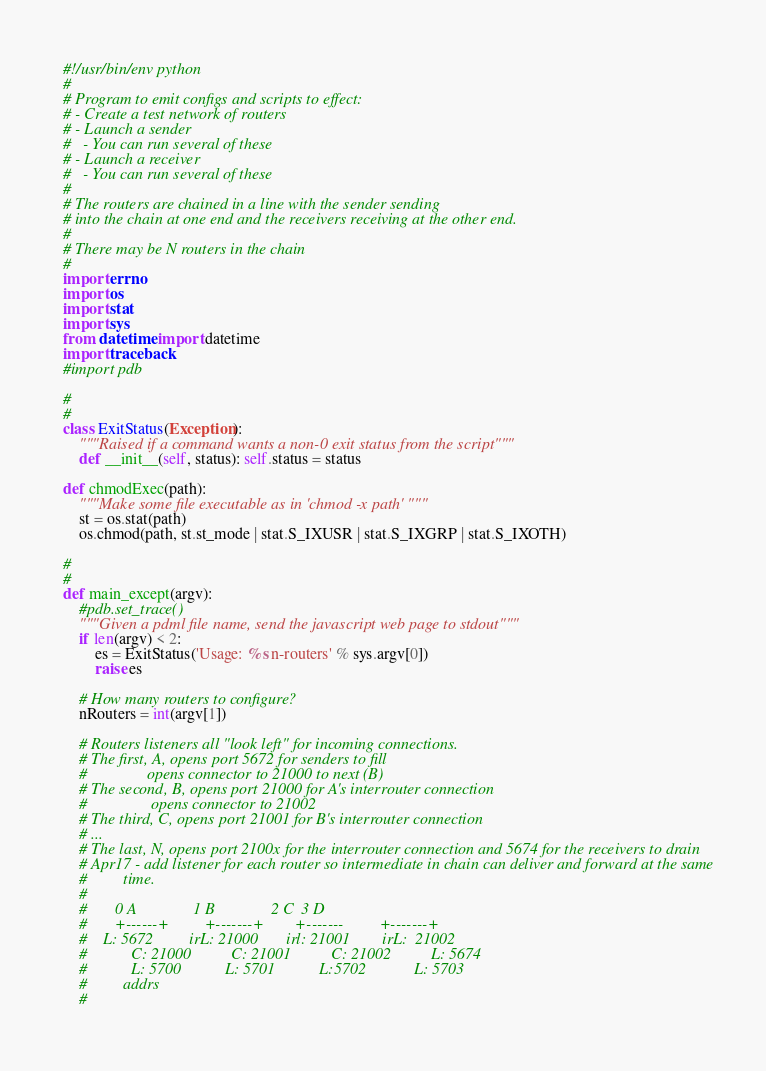Convert code to text. <code><loc_0><loc_0><loc_500><loc_500><_Python_>#!/usr/bin/env python
#
# Program to emit configs and scripts to effect:
# - Create a test network of routers
# - Launch a sender
#   - You can run several of these
# - Launch a receiver
#   - You can run several of these
#
# The routers are chained in a line with the sender sending
# into the chain at one end and the receivers receiving at the other end.
#
# There may be N routers in the chain
#
import errno
import os
import stat
import sys
from datetime import datetime
import traceback
#import pdb

#
#
class ExitStatus(Exception):
    """Raised if a command wants a non-0 exit status from the script"""
    def __init__(self, status): self.status = status

def chmodExec(path):
    """Make some file executable as in 'chmod -x path' """
    st = os.stat(path)
    os.chmod(path, st.st_mode | stat.S_IXUSR | stat.S_IXGRP | stat.S_IXOTH)

#
#
def main_except(argv):
    #pdb.set_trace()
    """Given a pdml file name, send the javascript web page to stdout"""
    if len(argv) < 2:
        es = ExitStatus('Usage: %s n-routers' % sys.argv[0])
        raise es

    # How many routers to configure?
    nRouters = int(argv[1])

    # Routers listeners all "look left" for incoming connections.
    # The first, A, opens port 5672 for senders to fill
    #               opens connector to 21000 to next (B)
    # The second, B, opens port 21000 for A's interrouter connection
    #                opens connector to 21002
    # The third, C, opens port 21001 for B's interrouter connection
    # ...
    # The last, N, opens port 2100x for the interrouter connection and 5674 for the receivers to drain
    # Apr17 - add listener for each router so intermediate in chain can deliver and forward at the same
    #         time.
    #
    #       0 A              1 B              2 C  3 D
    #       +------+         +-------+        +-------         +-------+
    #    L: 5672         irL: 21000       irl: 21001        irL:  21002
    #           C: 21000          C: 21001          C: 21002          L: 5674
    #           L: 5700           L: 5701           L:5702            L: 5703
    #         addrs
    #</code> 